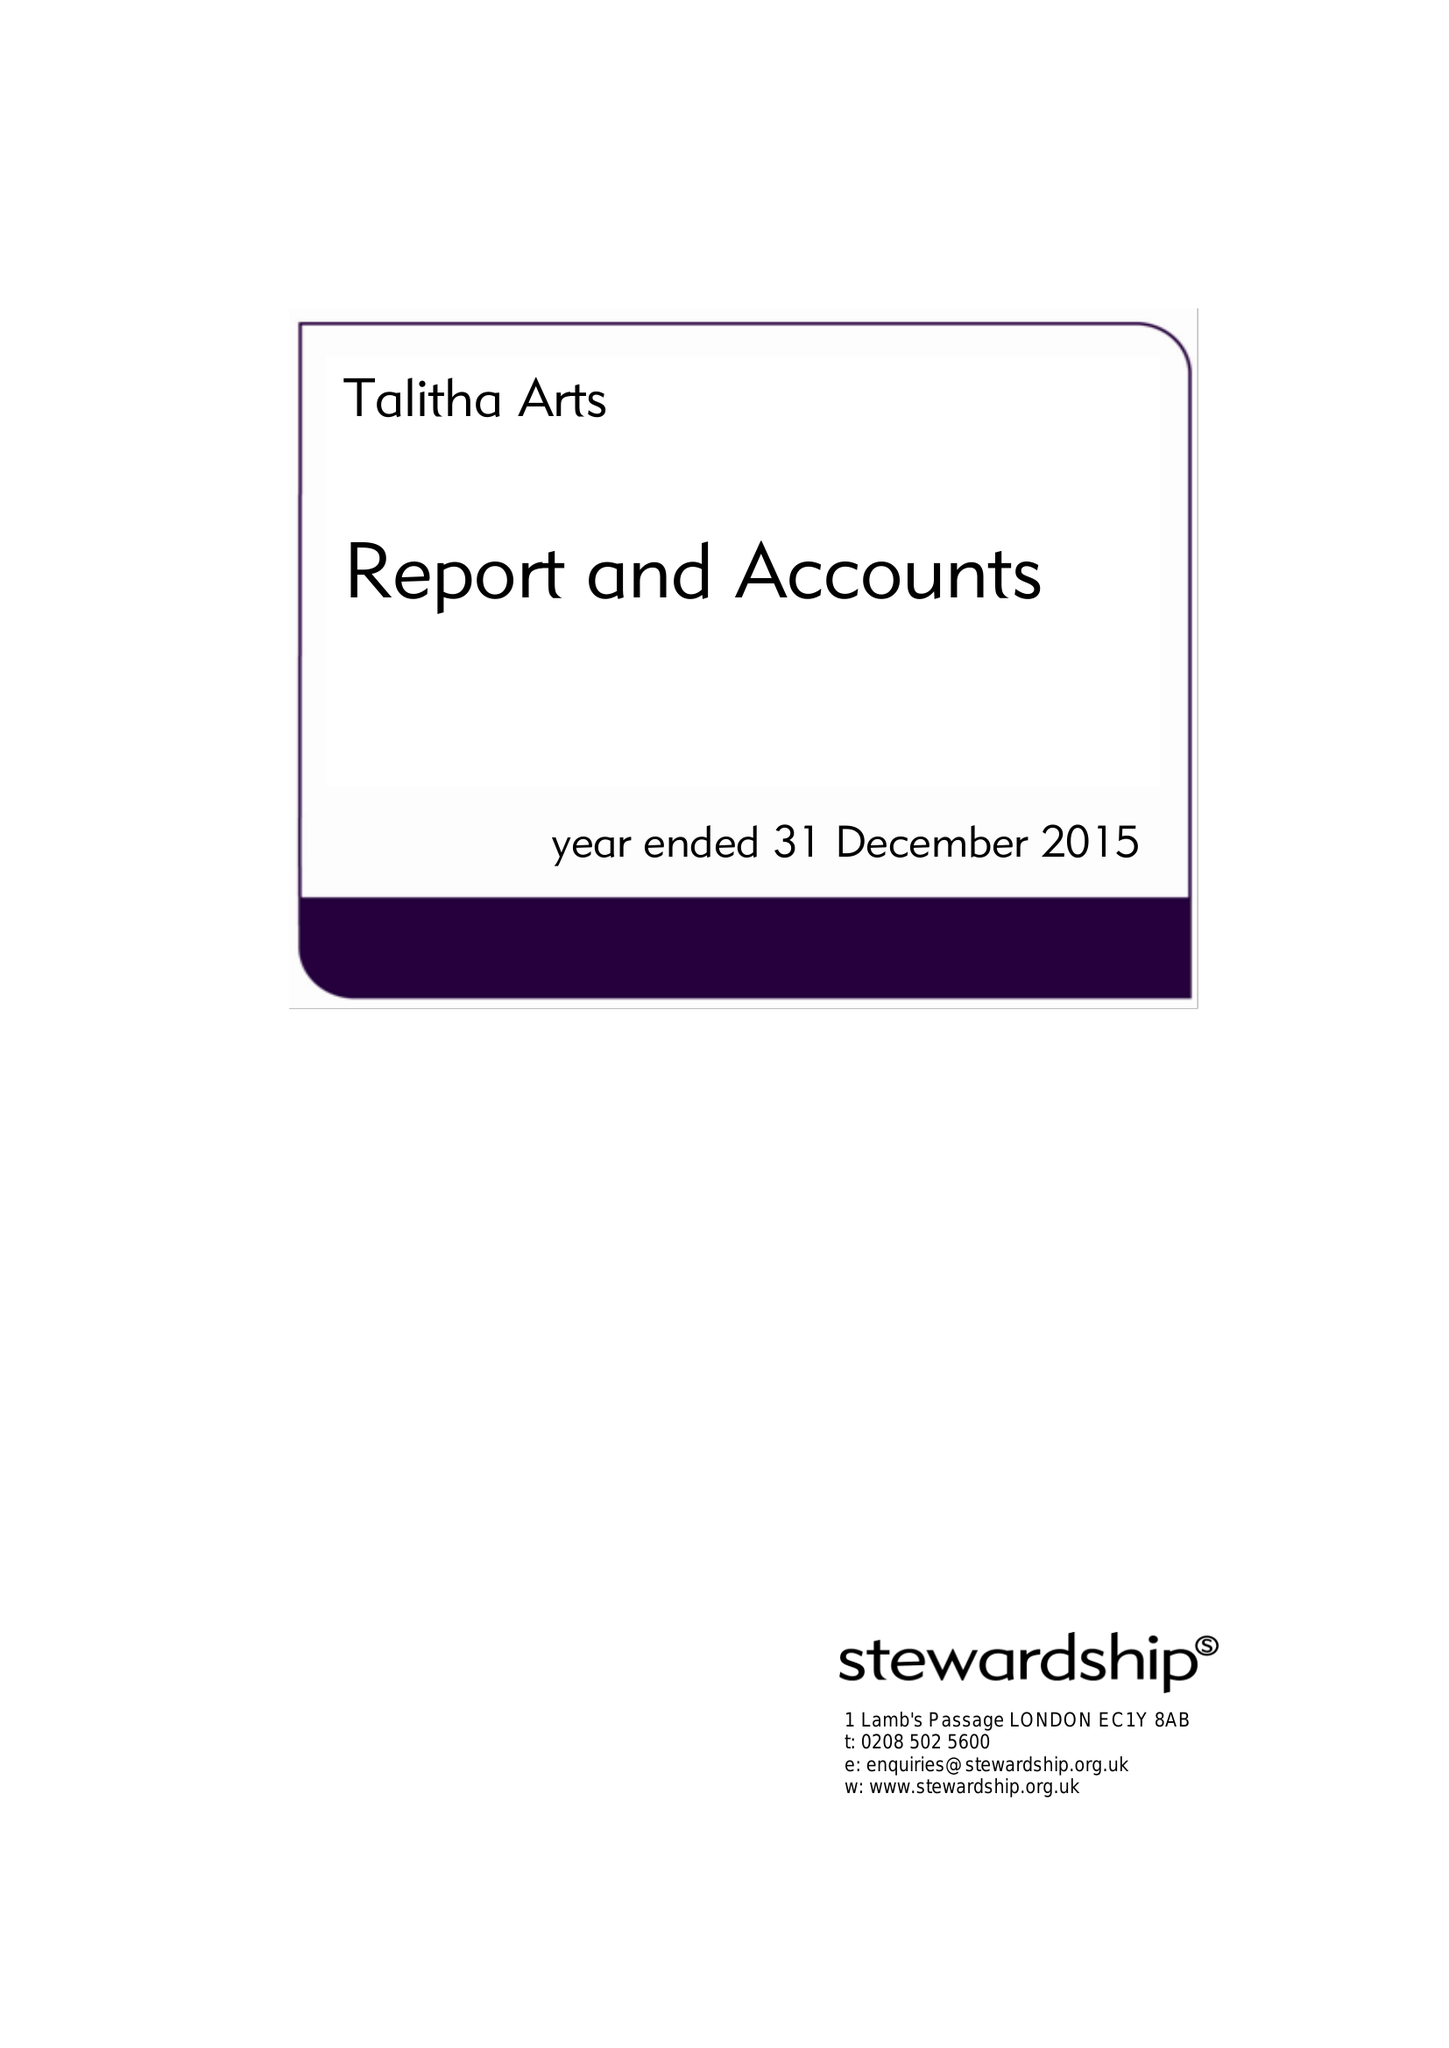What is the value for the address__street_line?
Answer the question using a single word or phrase. 5 CLARENCE ROAD 